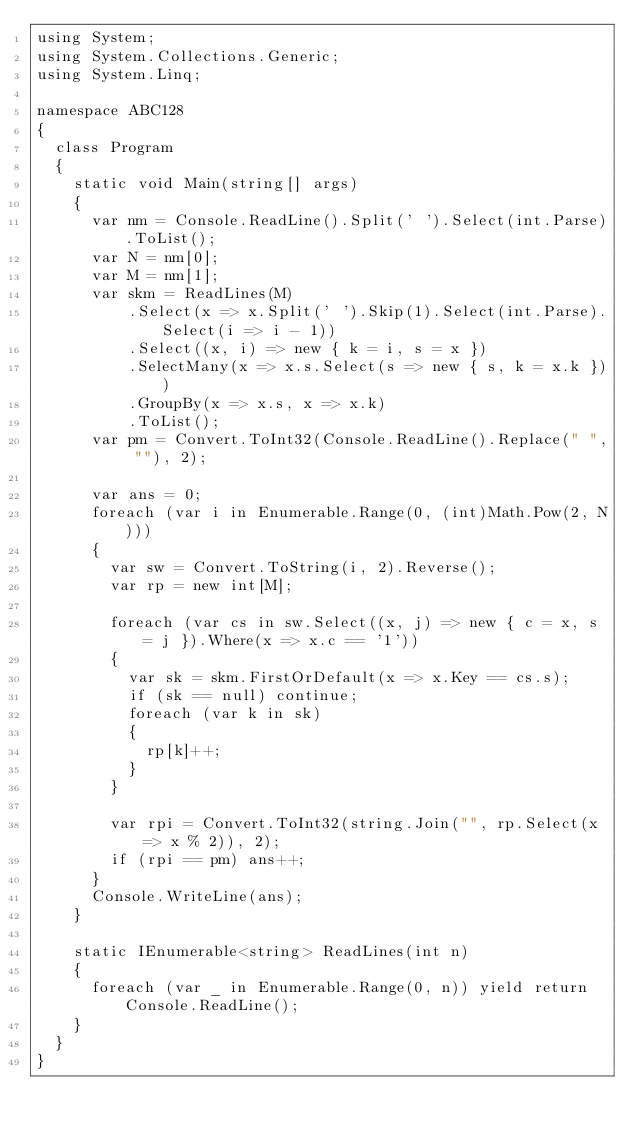Convert code to text. <code><loc_0><loc_0><loc_500><loc_500><_C#_>using System;
using System.Collections.Generic;
using System.Linq;

namespace ABC128
{
	class Program
	{
		static void Main(string[] args)
		{
			var nm = Console.ReadLine().Split(' ').Select(int.Parse).ToList();
			var N = nm[0];
			var M = nm[1];
			var skm = ReadLines(M)
					.Select(x => x.Split(' ').Skip(1).Select(int.Parse).Select(i => i - 1))
					.Select((x, i) => new { k = i, s = x })
					.SelectMany(x => x.s.Select(s => new { s, k = x.k }))
					.GroupBy(x => x.s, x => x.k)
					.ToList();
			var pm = Convert.ToInt32(Console.ReadLine().Replace(" ", ""), 2);

			var ans = 0;
			foreach (var i in Enumerable.Range(0, (int)Math.Pow(2, N)))
			{
				var sw = Convert.ToString(i, 2).Reverse();
				var rp = new int[M];

				foreach (var cs in sw.Select((x, j) => new { c = x, s = j }).Where(x => x.c == '1'))
				{
					var sk = skm.FirstOrDefault(x => x.Key == cs.s);
					if (sk == null) continue;
					foreach (var k in sk)
					{
						rp[k]++;
					}
				}

				var rpi = Convert.ToInt32(string.Join("", rp.Select(x => x % 2)), 2);
				if (rpi == pm) ans++;
			}
			Console.WriteLine(ans);
		}

		static IEnumerable<string> ReadLines(int n)
		{
			foreach (var _ in Enumerable.Range(0, n)) yield return Console.ReadLine();
		}
	}
}
</code> 